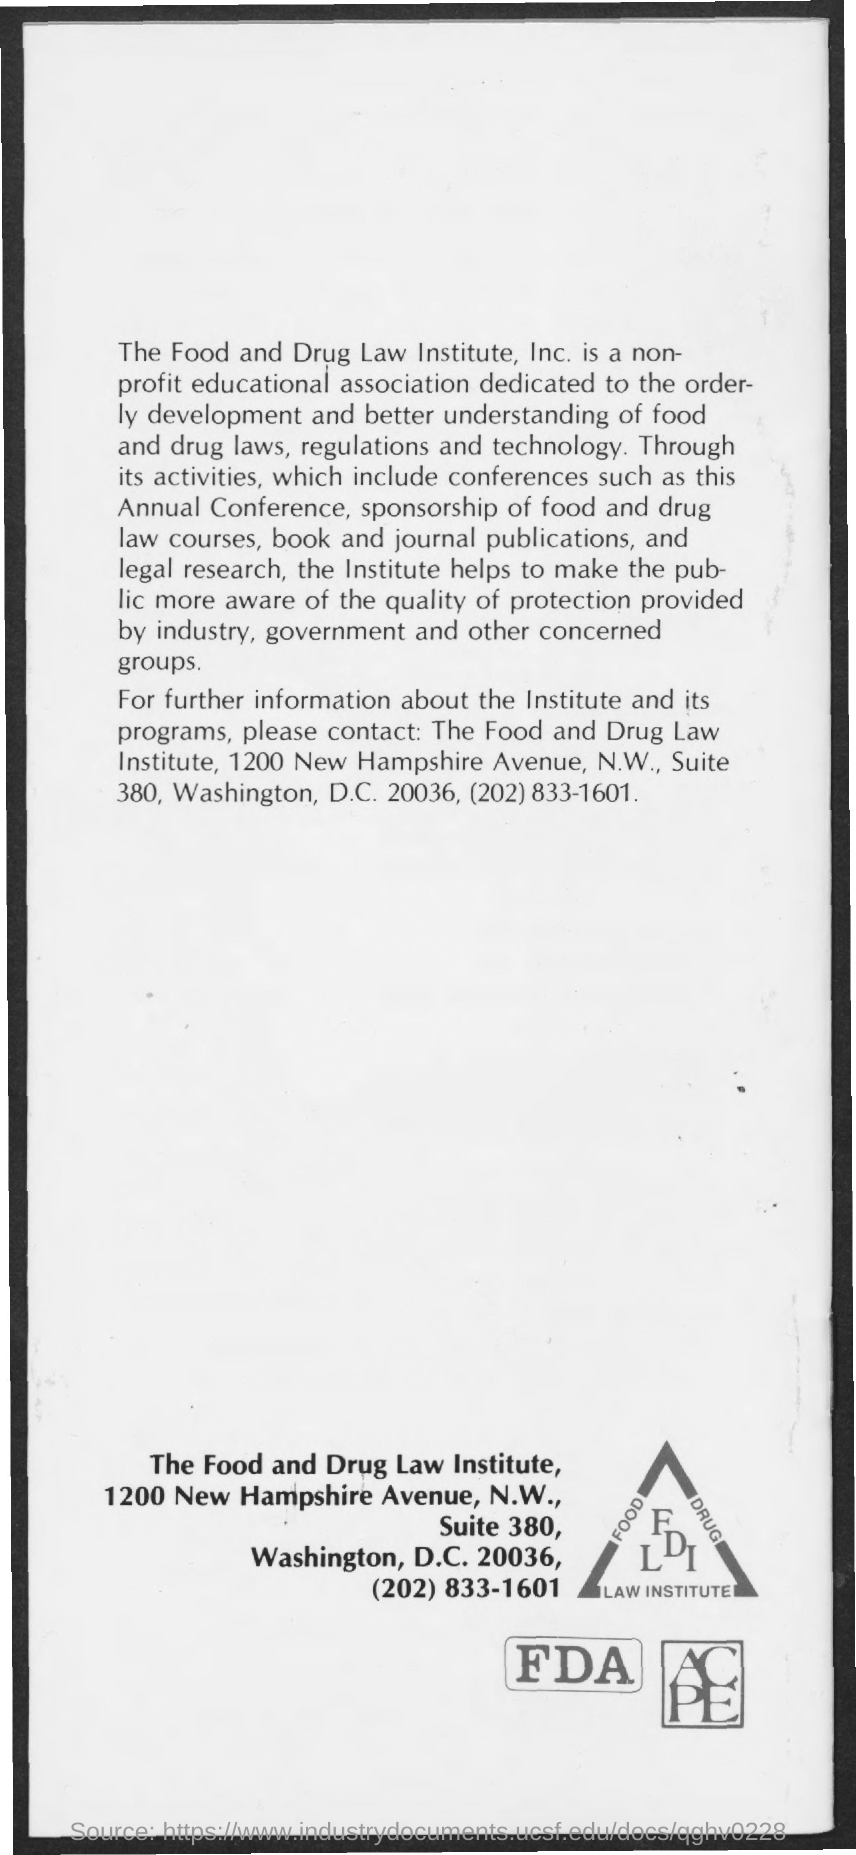Mention a couple of crucial points in this snapshot. The contact number is (202) 833-1601. FDLI is a non-profit educational association that is dedicated to promoting the understanding of food and drug law and policy. 